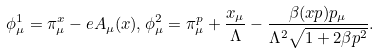<formula> <loc_0><loc_0><loc_500><loc_500>\phi ^ { 1 } _ { \mu } = \pi ^ { x } _ { \mu } - e A _ { \mu } ( x ) , \phi ^ { 2 } _ { \mu } = \pi ^ { p } _ { \mu } + \frac { x _ { \mu } } { \Lambda } - \frac { \beta ( x p ) p _ { \mu } } { \Lambda ^ { 2 } \sqrt { 1 + 2 \beta p ^ { 2 } } } .</formula> 